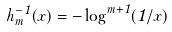<formula> <loc_0><loc_0><loc_500><loc_500>h _ { m } ^ { - 1 } ( x ) = - \log ^ { m + 1 } ( 1 / x )</formula> 